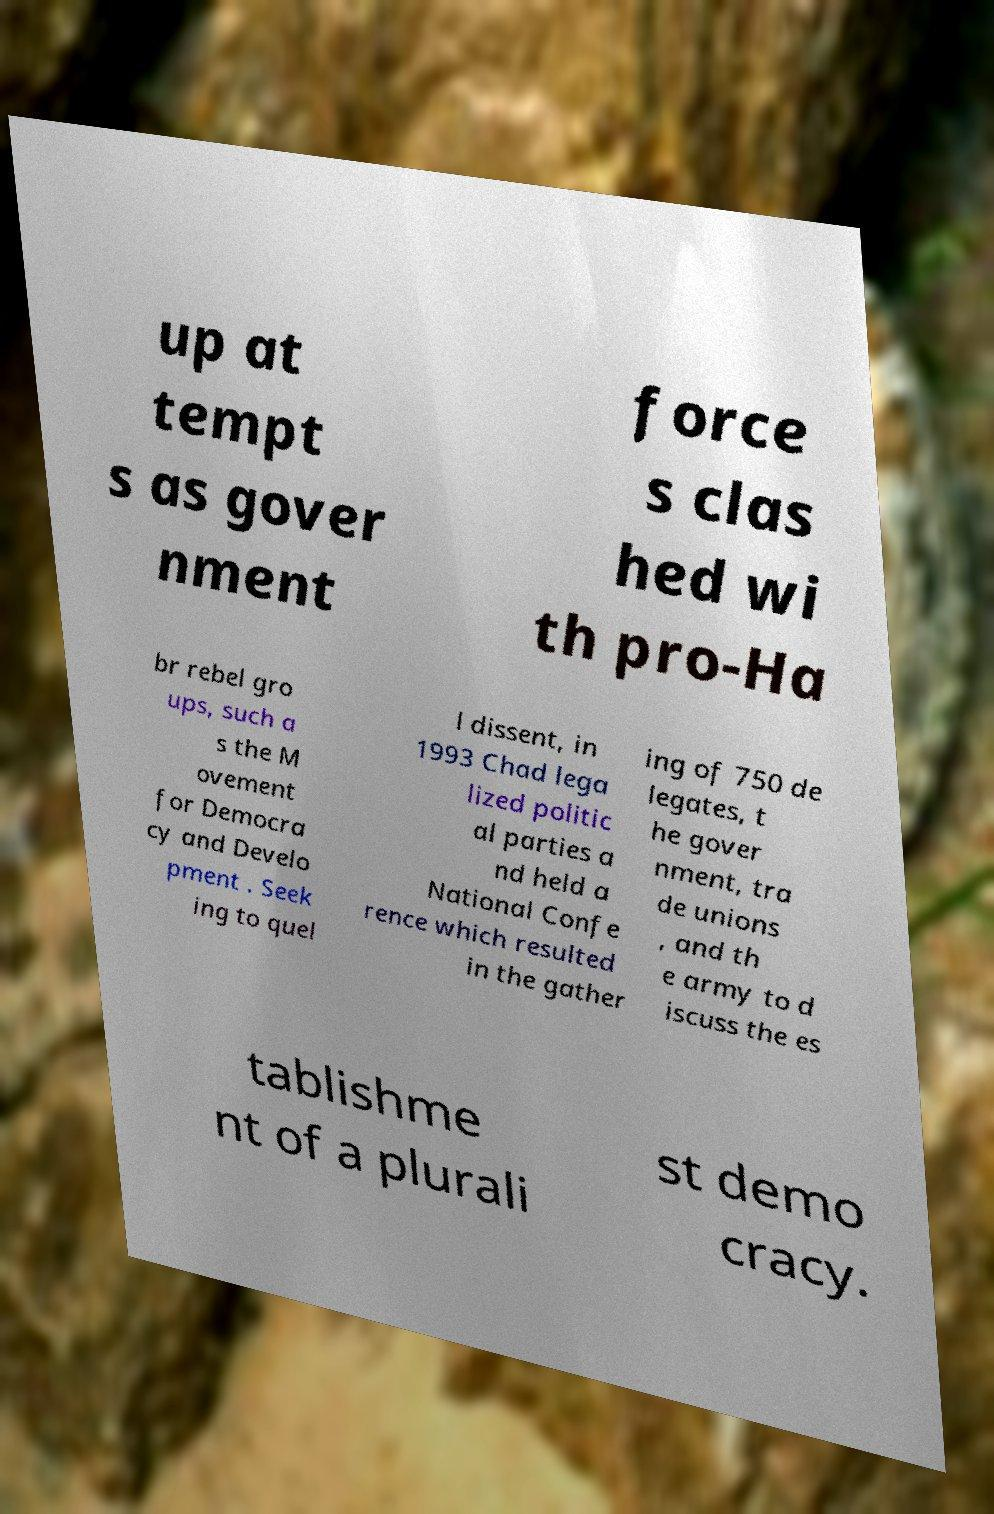Please read and relay the text visible in this image. What does it say? up at tempt s as gover nment force s clas hed wi th pro-Ha br rebel gro ups, such a s the M ovement for Democra cy and Develo pment . Seek ing to quel l dissent, in 1993 Chad lega lized politic al parties a nd held a National Confe rence which resulted in the gather ing of 750 de legates, t he gover nment, tra de unions , and th e army to d iscuss the es tablishme nt of a plurali st demo cracy. 